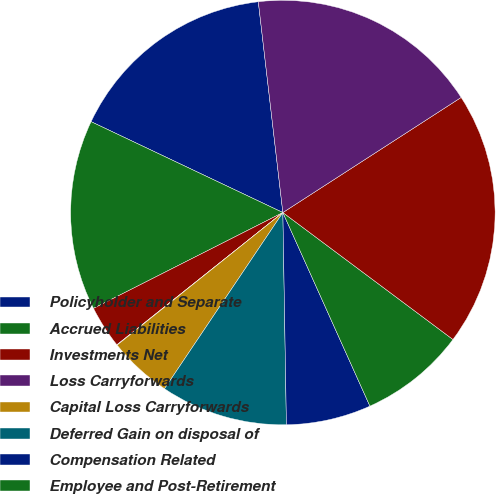Convert chart. <chart><loc_0><loc_0><loc_500><loc_500><pie_chart><fcel>Policyholder and Separate<fcel>Accrued Liabilities<fcel>Investments Net<fcel>Loss Carryforwards<fcel>Capital Loss Carryforwards<fcel>Deferred Gain on disposal of<fcel>Compensation Related<fcel>Employee and Post-Retirement<fcel>Total Deferred Tax Asset<fcel>Deferred Acquisition Costs<nl><fcel>16.11%<fcel>14.5%<fcel>3.25%<fcel>0.03%<fcel>4.85%<fcel>9.68%<fcel>6.46%<fcel>8.07%<fcel>19.33%<fcel>17.72%<nl></chart> 